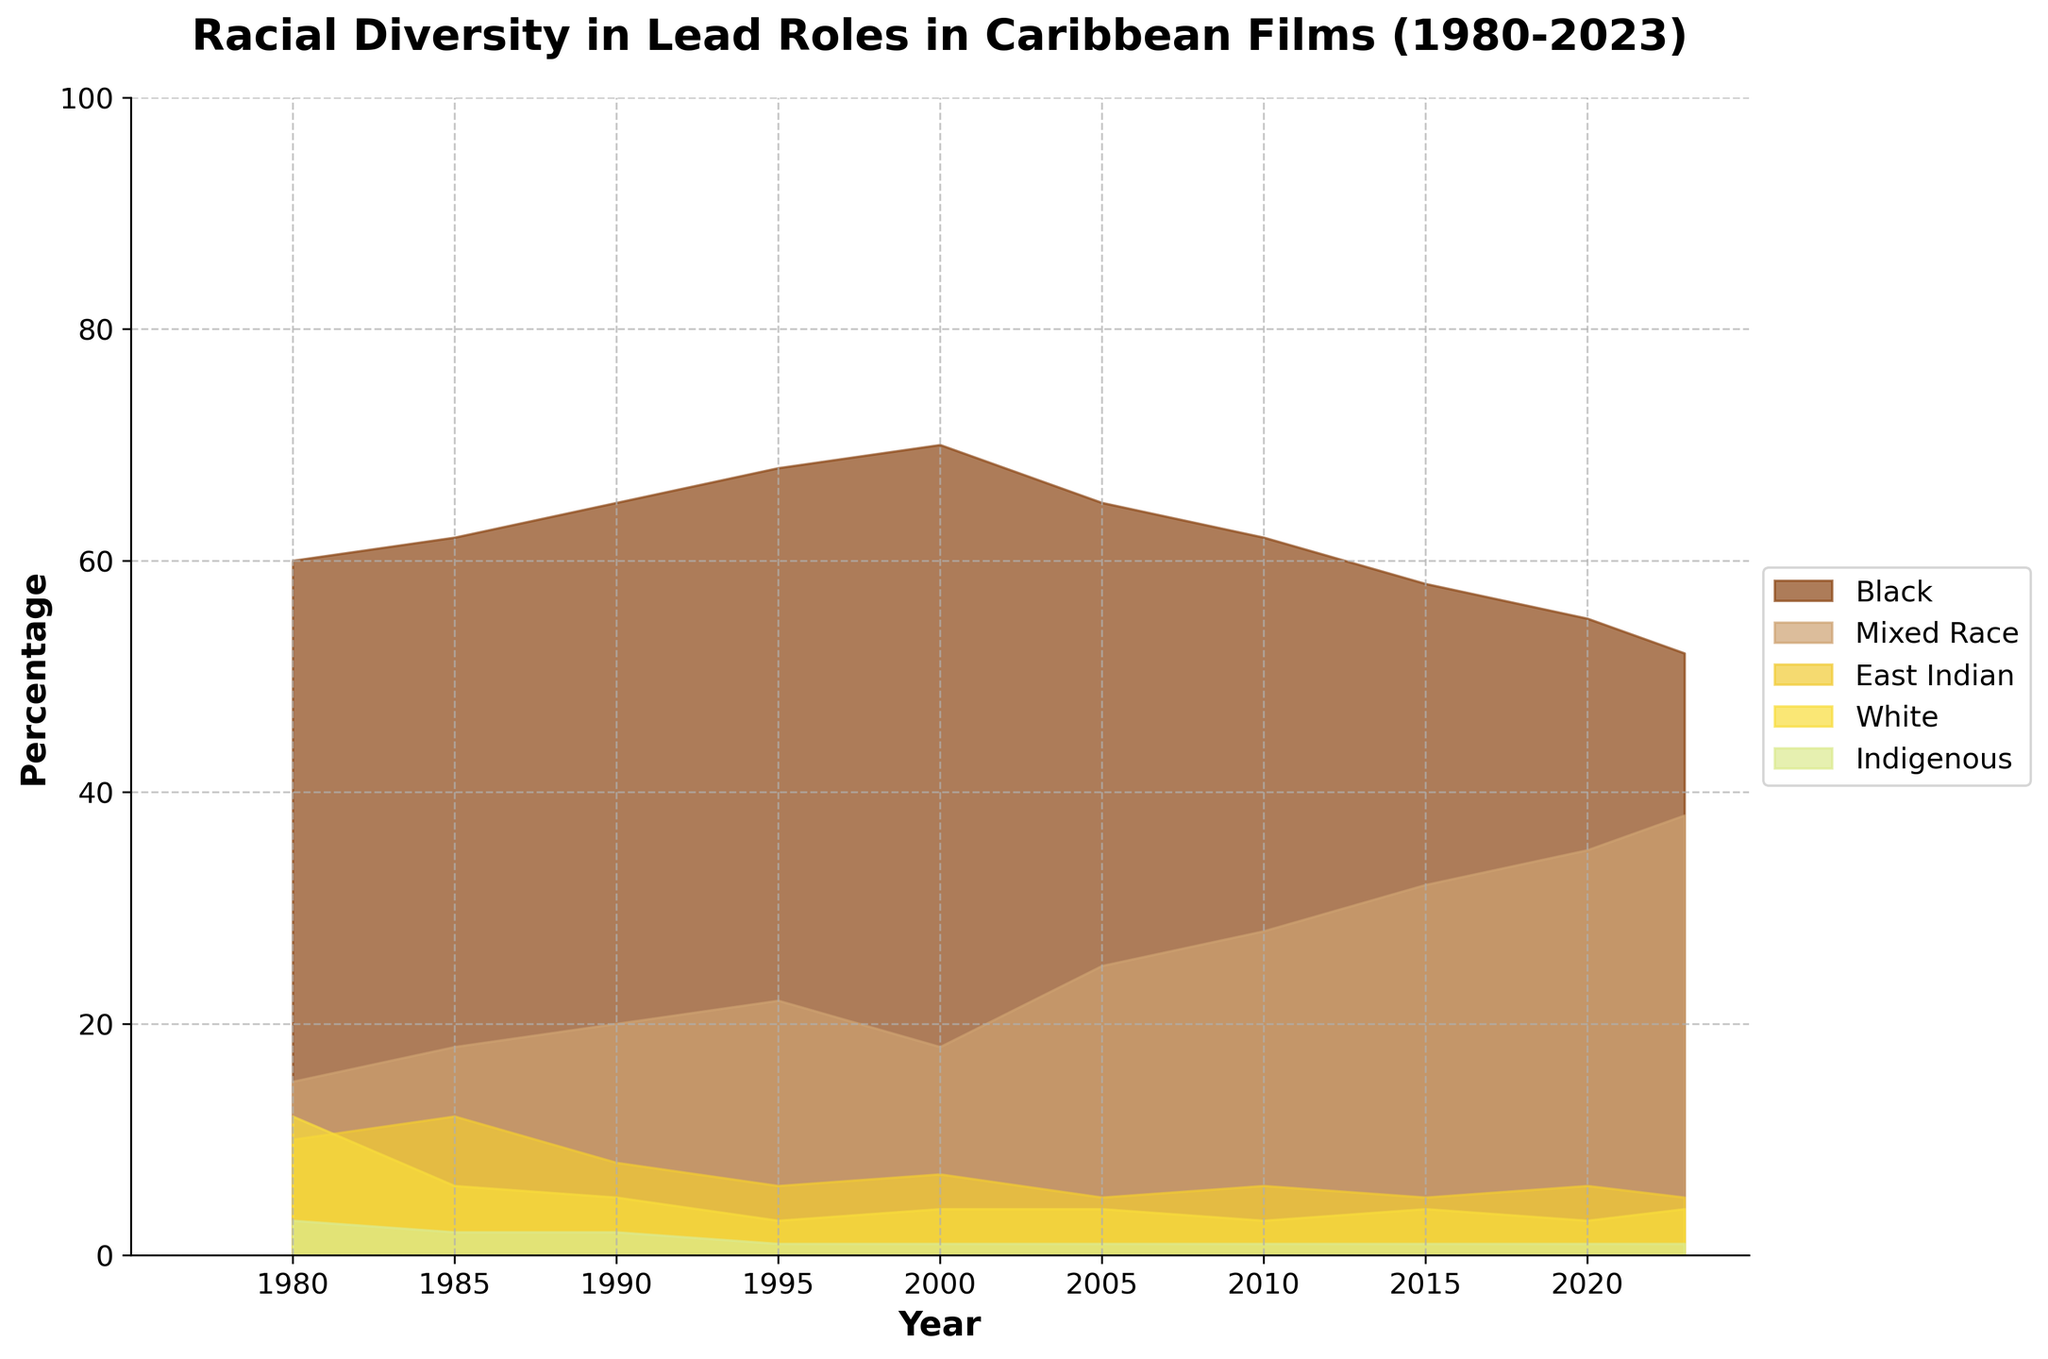What is the title of the chart? The title of the chart is usually placed at the top of the figure. Here it mentions "Racial Diversity in Lead Roles in Caribbean Films (1980-2023)."
Answer: Racial Diversity in Lead Roles in Caribbean Films (1980-2023) Which racial group had the highest percentage of lead roles in 1990? By observing the chart, you can see the highest point for each year, and for 1990, the peak is for the "Black" racial group.
Answer: Black What is the trend of the "Mixed Race" category from 1980 to 2023? By following the "Mixed Race" segment over time, you'll notice an upward trend from 15% in 1980 to 38% in 2023.
Answer: Increasing At what year did the percentage of "Black" lead roles start to decline? Looking at the graph for the "Black" segment, the decline starts around the year 2000 when it decreased from 70%.
Answer: Around 2000 How do the percentages of "East Indian" lead roles in 1980 and 2023 compare? Check the values for the "East Indian" group at 1980 (10%) and 2023 (5%), the percentage has decreased over this period.
Answer: The percentage has decreased What is the sum of percentages for "White" and "Indigenous" races in 1985? Add the values for both races in 1985: 6% (White) + 2% (Indigenous) = 8%.
Answer: 8% Which group shows the most fluctuation over the years? Observing all segments, the "Mixed Race" category shows the most variance, starting at 15%, peaking up to 38%.
Answer: Mixed Race Between which years did the "Mixed Race" category see the most significant increase? Between 2010 to 2015, "Mixed Race" went from 28% to 32%, and further to 38% by 2023. The significant initial increase is seen between 2010 and 2020.
Answer: Between 2010 and 2015 Which racial group's percentage remained almost constant between 2000 and 2023? By observing the charts, the "Indigenous" group's percentage has remained mostly constant at 1%.
Answer: Indigenous What is the difference in the percentage of "Black" lead roles between the years 1980 and 2023? Subtract the percentage of "Black" in 2023 (52%) from 1980 (60%): 60% - 52% = 8%.
Answer: 8% 